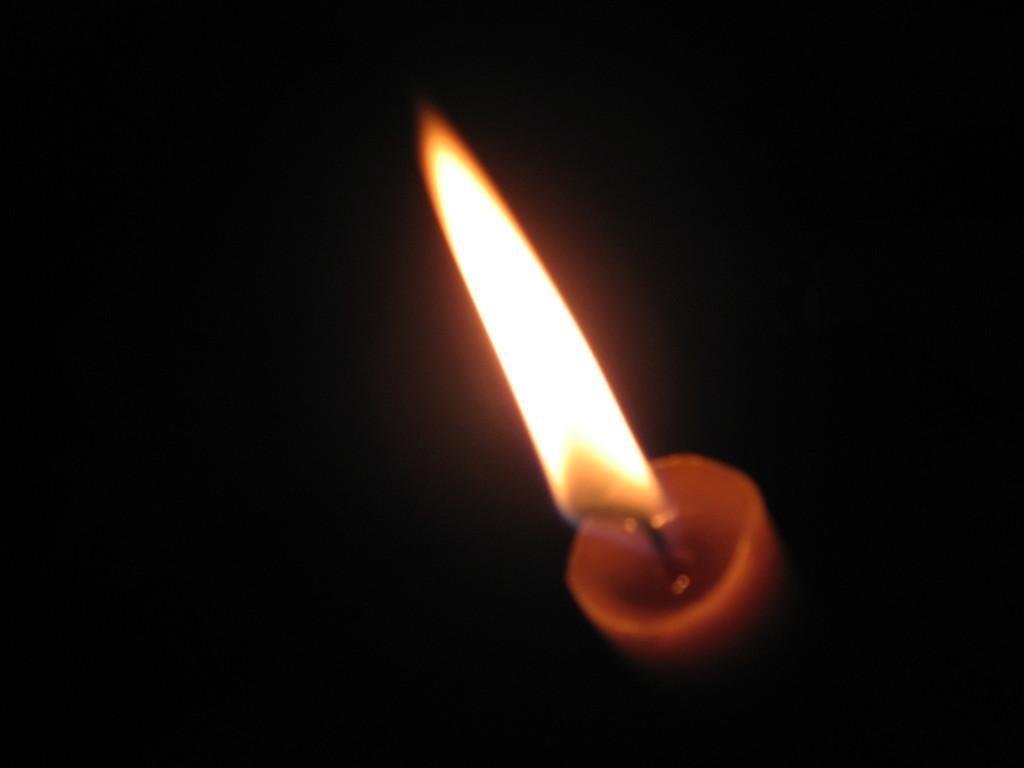What object is present at the bottom side of the image? There is a candle in the image, located at the bottom side. What type of airplane is flying above the candle in the image? There is no airplane present in the image; it only features a candle located at the bottom side. 